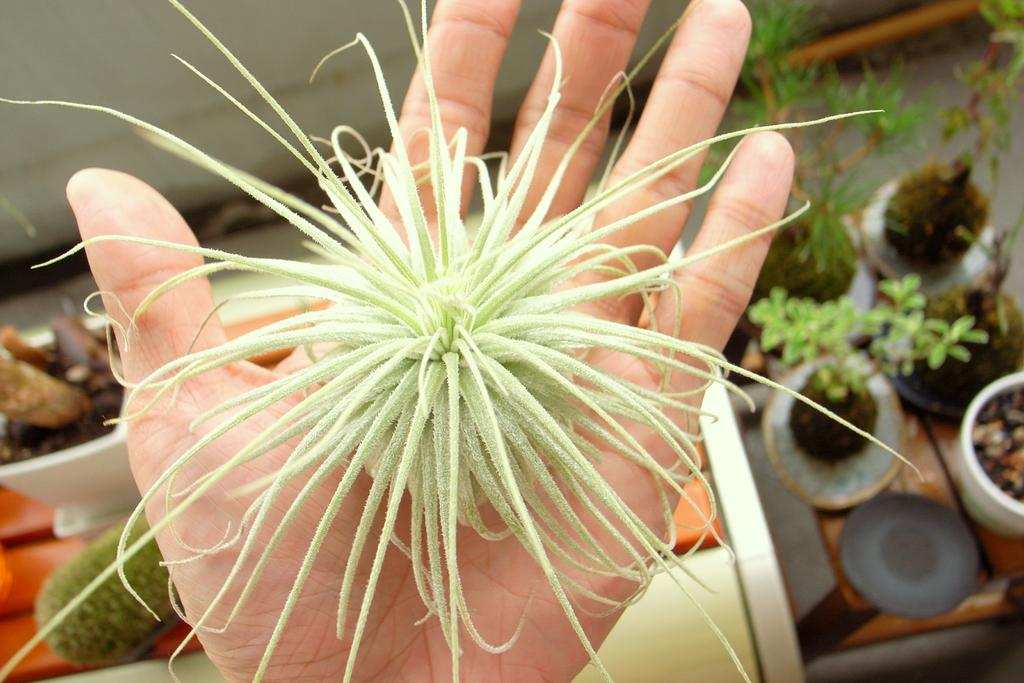What part of the human body is visible in the image? There is a human hand in the image. What is the hand holding or touching? There is an object in the hand. What type of objects can be seen in the image? There are pots and containers in the image. What is the surface that the objects are placed on? There is a table in the image. Where are the containers located in the image? The containers are on the left side of the image. What is the background of the image? There is a wall in the image. What type of shoe can be seen on the wall in the image? There is no shoe present on the wall in the image. 